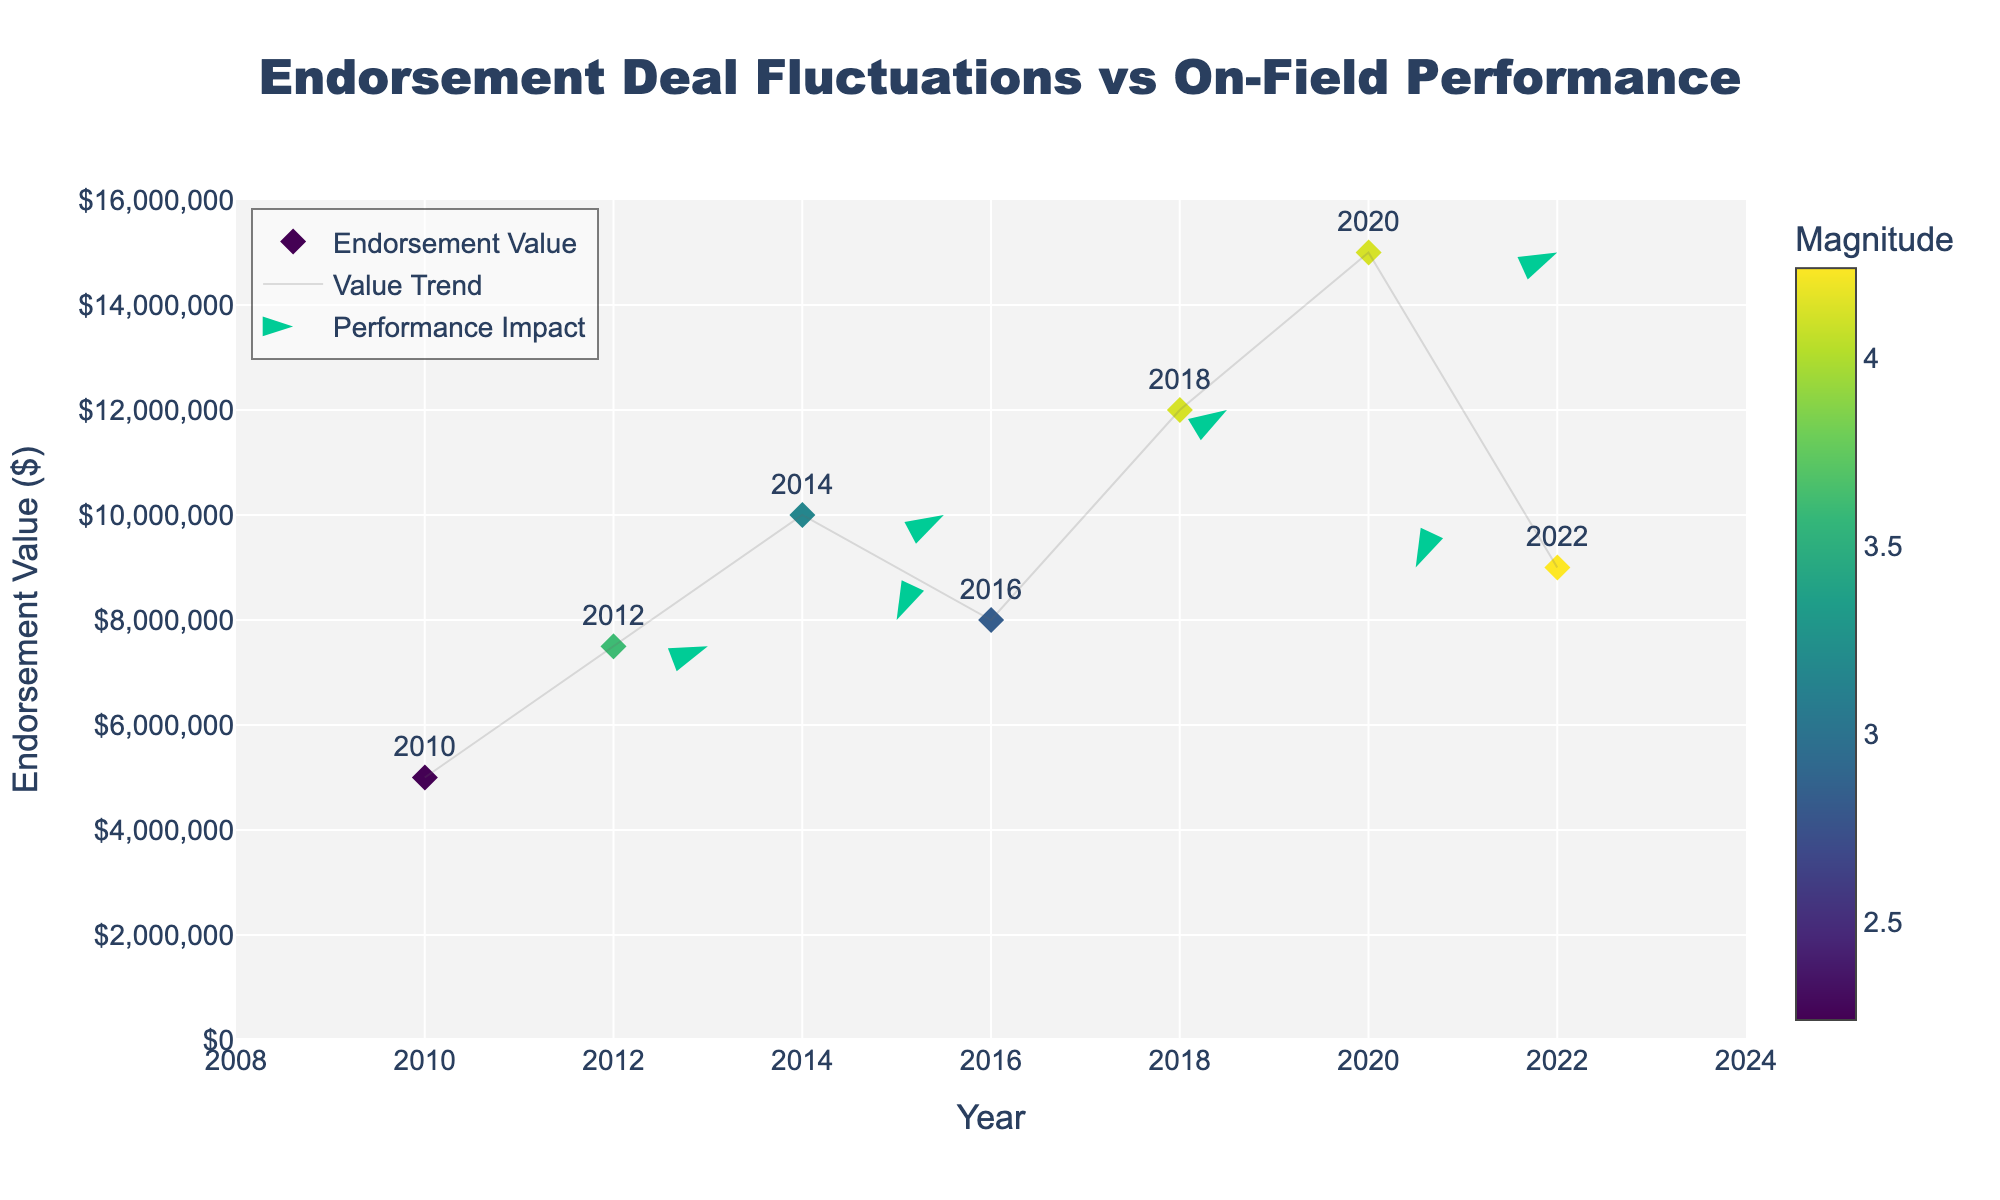What is the title of the figure? The title is displayed at the top center of the figure, giving context to what is being visualized.
Answer: "Endorsement Deal Fluctuations vs On-Field Performance" How many data points are represented in the figure? By counting the distinct symbols/dots or text labels, we can see how many data points are present.
Answer: 7 Which year has the highest endorsement value? Observing the position of the dots/text along the y-axis, the highest point indicates the year with the highest value.
Answer: 2020 What is the range of endorsement values shown on the y-axis? Looking at the labels and ticks on the y-axis, we can see the minimum and maximum values shown.
Answer: $0 to $15,000,000 What trend can be observed in the endorsement values from 2018 to 2020? Analyzing the points on the figure and connecting them, we see whether the trend is increasing, decreasing, or stable.
Answer: Increasing What is the average magnitude of fluctuations in the endorsement values over the years? Sum up the magnitudes and divide by the number of data points: (2.24 + 3.61 + 3.16 + 2.83 + 4.12 + 4.12 + 4.24) / 7.
Answer: 3.48 Which year experiences the largest fluctuation in endorsement value? By comparing the magnitudes (color intensity or value) at each data point, the year with the highest magnitude is identified.
Answer: 2022 Which year saw a decrease in endorsement value with a negative performance impact? Checking for a downward arrow (negative y-component of the vector) and decrease in endorsement value.
Answer: 2016 Between 2014 and 2016, how did the endorsement value change? Compare the y-values of the points for 2014 and 2016 and note the change direction and amount.
Answer: Decreased by $2,000,000 How does the magnitude of the performance impact in 2018 compare to 2016? Observing the color shade or directly comparing the magnitude values at 2018 and 2016.
Answer: 2018 has a greater magnitude (4.12 vs 2.83) 